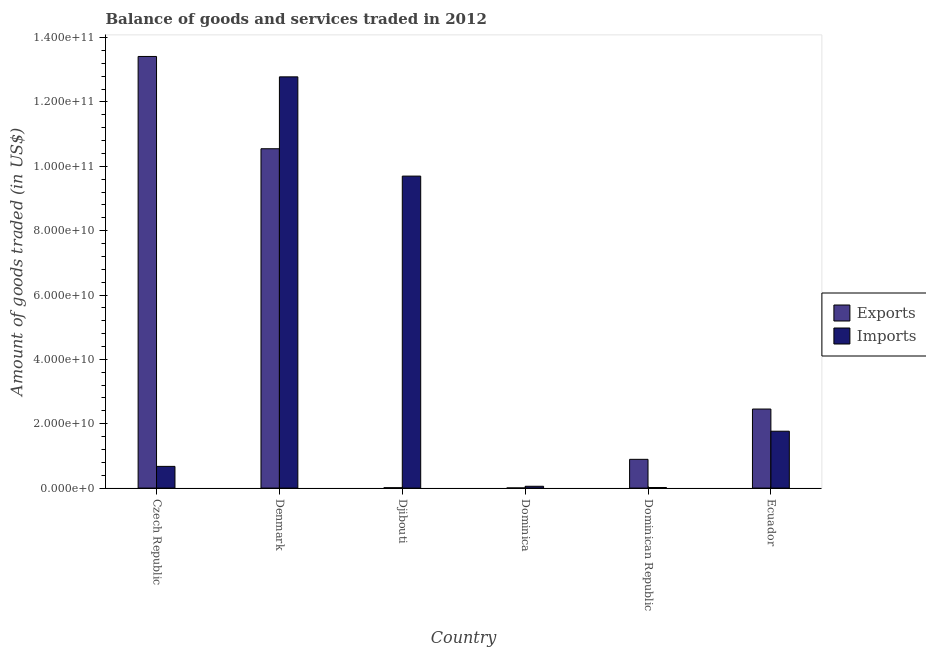How many different coloured bars are there?
Provide a short and direct response. 2. How many groups of bars are there?
Offer a terse response. 6. What is the label of the 5th group of bars from the left?
Your answer should be very brief. Dominican Republic. In how many cases, is the number of bars for a given country not equal to the number of legend labels?
Your answer should be very brief. 0. What is the amount of goods exported in Dominica?
Give a very brief answer. 3.86e+07. Across all countries, what is the maximum amount of goods exported?
Offer a terse response. 1.34e+11. Across all countries, what is the minimum amount of goods imported?
Your answer should be compact. 1.83e+08. In which country was the amount of goods imported maximum?
Ensure brevity in your answer.  Denmark. In which country was the amount of goods imported minimum?
Provide a succinct answer. Dominican Republic. What is the total amount of goods imported in the graph?
Offer a terse response. 2.50e+11. What is the difference between the amount of goods exported in Dominican Republic and that in Ecuador?
Your response must be concise. -1.56e+1. What is the difference between the amount of goods imported in Ecuador and the amount of goods exported in Djibouti?
Give a very brief answer. 1.76e+1. What is the average amount of goods exported per country?
Keep it short and to the point. 4.55e+1. What is the difference between the amount of goods imported and amount of goods exported in Dominica?
Your answer should be compact. 5.26e+08. In how many countries, is the amount of goods exported greater than 32000000000 US$?
Keep it short and to the point. 2. What is the ratio of the amount of goods exported in Denmark to that in Dominican Republic?
Offer a terse response. 11.8. Is the difference between the amount of goods exported in Czech Republic and Dominica greater than the difference between the amount of goods imported in Czech Republic and Dominica?
Your answer should be very brief. Yes. What is the difference between the highest and the second highest amount of goods imported?
Keep it short and to the point. 3.08e+1. What is the difference between the highest and the lowest amount of goods exported?
Your answer should be very brief. 1.34e+11. Is the sum of the amount of goods imported in Djibouti and Ecuador greater than the maximum amount of goods exported across all countries?
Ensure brevity in your answer.  No. What does the 2nd bar from the left in Djibouti represents?
Your answer should be compact. Imports. What does the 2nd bar from the right in Dominica represents?
Your answer should be compact. Exports. How many bars are there?
Offer a very short reply. 12. How many countries are there in the graph?
Ensure brevity in your answer.  6. Where does the legend appear in the graph?
Offer a very short reply. Center right. How many legend labels are there?
Ensure brevity in your answer.  2. How are the legend labels stacked?
Your answer should be compact. Vertical. What is the title of the graph?
Your answer should be compact. Balance of goods and services traded in 2012. What is the label or title of the Y-axis?
Make the answer very short. Amount of goods traded (in US$). What is the Amount of goods traded (in US$) of Exports in Czech Republic?
Your answer should be very brief. 1.34e+11. What is the Amount of goods traded (in US$) in Imports in Czech Republic?
Your answer should be very brief. 6.74e+09. What is the Amount of goods traded (in US$) of Exports in Denmark?
Offer a terse response. 1.05e+11. What is the Amount of goods traded (in US$) of Imports in Denmark?
Offer a terse response. 1.28e+11. What is the Amount of goods traded (in US$) in Exports in Djibouti?
Give a very brief answer. 1.11e+08. What is the Amount of goods traded (in US$) of Imports in Djibouti?
Provide a short and direct response. 9.69e+1. What is the Amount of goods traded (in US$) of Exports in Dominica?
Your answer should be very brief. 3.86e+07. What is the Amount of goods traded (in US$) of Imports in Dominica?
Your answer should be very brief. 5.64e+08. What is the Amount of goods traded (in US$) in Exports in Dominican Republic?
Keep it short and to the point. 8.94e+09. What is the Amount of goods traded (in US$) of Imports in Dominican Republic?
Offer a very short reply. 1.83e+08. What is the Amount of goods traded (in US$) of Exports in Ecuador?
Your answer should be compact. 2.46e+1. What is the Amount of goods traded (in US$) in Imports in Ecuador?
Your answer should be very brief. 1.77e+1. Across all countries, what is the maximum Amount of goods traded (in US$) of Exports?
Offer a terse response. 1.34e+11. Across all countries, what is the maximum Amount of goods traded (in US$) of Imports?
Your answer should be very brief. 1.28e+11. Across all countries, what is the minimum Amount of goods traded (in US$) in Exports?
Your answer should be very brief. 3.86e+07. Across all countries, what is the minimum Amount of goods traded (in US$) of Imports?
Give a very brief answer. 1.83e+08. What is the total Amount of goods traded (in US$) of Exports in the graph?
Offer a very short reply. 2.73e+11. What is the total Amount of goods traded (in US$) in Imports in the graph?
Your answer should be very brief. 2.50e+11. What is the difference between the Amount of goods traded (in US$) of Exports in Czech Republic and that in Denmark?
Offer a terse response. 2.87e+1. What is the difference between the Amount of goods traded (in US$) in Imports in Czech Republic and that in Denmark?
Your answer should be very brief. -1.21e+11. What is the difference between the Amount of goods traded (in US$) of Exports in Czech Republic and that in Djibouti?
Your response must be concise. 1.34e+11. What is the difference between the Amount of goods traded (in US$) in Imports in Czech Republic and that in Djibouti?
Ensure brevity in your answer.  -9.02e+1. What is the difference between the Amount of goods traded (in US$) in Exports in Czech Republic and that in Dominica?
Your answer should be very brief. 1.34e+11. What is the difference between the Amount of goods traded (in US$) in Imports in Czech Republic and that in Dominica?
Offer a terse response. 6.18e+09. What is the difference between the Amount of goods traded (in US$) of Exports in Czech Republic and that in Dominican Republic?
Your response must be concise. 1.25e+11. What is the difference between the Amount of goods traded (in US$) of Imports in Czech Republic and that in Dominican Republic?
Your answer should be compact. 6.56e+09. What is the difference between the Amount of goods traded (in US$) in Exports in Czech Republic and that in Ecuador?
Your answer should be very brief. 1.10e+11. What is the difference between the Amount of goods traded (in US$) in Imports in Czech Republic and that in Ecuador?
Ensure brevity in your answer.  -1.09e+1. What is the difference between the Amount of goods traded (in US$) in Exports in Denmark and that in Djibouti?
Your answer should be compact. 1.05e+11. What is the difference between the Amount of goods traded (in US$) of Imports in Denmark and that in Djibouti?
Your response must be concise. 3.08e+1. What is the difference between the Amount of goods traded (in US$) in Exports in Denmark and that in Dominica?
Provide a short and direct response. 1.05e+11. What is the difference between the Amount of goods traded (in US$) of Imports in Denmark and that in Dominica?
Offer a very short reply. 1.27e+11. What is the difference between the Amount of goods traded (in US$) in Exports in Denmark and that in Dominican Republic?
Offer a very short reply. 9.65e+1. What is the difference between the Amount of goods traded (in US$) of Imports in Denmark and that in Dominican Republic?
Your answer should be very brief. 1.28e+11. What is the difference between the Amount of goods traded (in US$) in Exports in Denmark and that in Ecuador?
Your response must be concise. 8.09e+1. What is the difference between the Amount of goods traded (in US$) in Imports in Denmark and that in Ecuador?
Make the answer very short. 1.10e+11. What is the difference between the Amount of goods traded (in US$) of Exports in Djibouti and that in Dominica?
Ensure brevity in your answer.  7.28e+07. What is the difference between the Amount of goods traded (in US$) in Imports in Djibouti and that in Dominica?
Offer a very short reply. 9.64e+1. What is the difference between the Amount of goods traded (in US$) of Exports in Djibouti and that in Dominican Republic?
Give a very brief answer. -8.82e+09. What is the difference between the Amount of goods traded (in US$) in Imports in Djibouti and that in Dominican Republic?
Your answer should be very brief. 9.68e+1. What is the difference between the Amount of goods traded (in US$) in Exports in Djibouti and that in Ecuador?
Keep it short and to the point. -2.45e+1. What is the difference between the Amount of goods traded (in US$) of Imports in Djibouti and that in Ecuador?
Make the answer very short. 7.93e+1. What is the difference between the Amount of goods traded (in US$) in Exports in Dominica and that in Dominican Republic?
Give a very brief answer. -8.90e+09. What is the difference between the Amount of goods traded (in US$) of Imports in Dominica and that in Dominican Republic?
Make the answer very short. 3.81e+08. What is the difference between the Amount of goods traded (in US$) of Exports in Dominica and that in Ecuador?
Your response must be concise. -2.45e+1. What is the difference between the Amount of goods traded (in US$) in Imports in Dominica and that in Ecuador?
Your answer should be compact. -1.71e+1. What is the difference between the Amount of goods traded (in US$) of Exports in Dominican Republic and that in Ecuador?
Provide a succinct answer. -1.56e+1. What is the difference between the Amount of goods traded (in US$) of Imports in Dominican Republic and that in Ecuador?
Your answer should be compact. -1.75e+1. What is the difference between the Amount of goods traded (in US$) of Exports in Czech Republic and the Amount of goods traded (in US$) of Imports in Denmark?
Provide a short and direct response. 6.34e+09. What is the difference between the Amount of goods traded (in US$) in Exports in Czech Republic and the Amount of goods traded (in US$) in Imports in Djibouti?
Keep it short and to the point. 3.72e+1. What is the difference between the Amount of goods traded (in US$) in Exports in Czech Republic and the Amount of goods traded (in US$) in Imports in Dominica?
Offer a terse response. 1.34e+11. What is the difference between the Amount of goods traded (in US$) in Exports in Czech Republic and the Amount of goods traded (in US$) in Imports in Dominican Republic?
Provide a short and direct response. 1.34e+11. What is the difference between the Amount of goods traded (in US$) in Exports in Czech Republic and the Amount of goods traded (in US$) in Imports in Ecuador?
Offer a very short reply. 1.16e+11. What is the difference between the Amount of goods traded (in US$) in Exports in Denmark and the Amount of goods traded (in US$) in Imports in Djibouti?
Give a very brief answer. 8.50e+09. What is the difference between the Amount of goods traded (in US$) in Exports in Denmark and the Amount of goods traded (in US$) in Imports in Dominica?
Offer a very short reply. 1.05e+11. What is the difference between the Amount of goods traded (in US$) of Exports in Denmark and the Amount of goods traded (in US$) of Imports in Dominican Republic?
Offer a terse response. 1.05e+11. What is the difference between the Amount of goods traded (in US$) of Exports in Denmark and the Amount of goods traded (in US$) of Imports in Ecuador?
Give a very brief answer. 8.78e+1. What is the difference between the Amount of goods traded (in US$) of Exports in Djibouti and the Amount of goods traded (in US$) of Imports in Dominica?
Your response must be concise. -4.53e+08. What is the difference between the Amount of goods traded (in US$) of Exports in Djibouti and the Amount of goods traded (in US$) of Imports in Dominican Republic?
Ensure brevity in your answer.  -7.20e+07. What is the difference between the Amount of goods traded (in US$) of Exports in Djibouti and the Amount of goods traded (in US$) of Imports in Ecuador?
Your response must be concise. -1.76e+1. What is the difference between the Amount of goods traded (in US$) of Exports in Dominica and the Amount of goods traded (in US$) of Imports in Dominican Republic?
Your response must be concise. -1.45e+08. What is the difference between the Amount of goods traded (in US$) of Exports in Dominica and the Amount of goods traded (in US$) of Imports in Ecuador?
Make the answer very short. -1.76e+1. What is the difference between the Amount of goods traded (in US$) in Exports in Dominican Republic and the Amount of goods traded (in US$) in Imports in Ecuador?
Provide a short and direct response. -8.74e+09. What is the average Amount of goods traded (in US$) of Exports per country?
Provide a short and direct response. 4.55e+1. What is the average Amount of goods traded (in US$) of Imports per country?
Give a very brief answer. 4.16e+1. What is the difference between the Amount of goods traded (in US$) of Exports and Amount of goods traded (in US$) of Imports in Czech Republic?
Provide a short and direct response. 1.27e+11. What is the difference between the Amount of goods traded (in US$) in Exports and Amount of goods traded (in US$) in Imports in Denmark?
Offer a very short reply. -2.23e+1. What is the difference between the Amount of goods traded (in US$) of Exports and Amount of goods traded (in US$) of Imports in Djibouti?
Your response must be concise. -9.68e+1. What is the difference between the Amount of goods traded (in US$) of Exports and Amount of goods traded (in US$) of Imports in Dominica?
Provide a succinct answer. -5.26e+08. What is the difference between the Amount of goods traded (in US$) in Exports and Amount of goods traded (in US$) in Imports in Dominican Republic?
Your answer should be very brief. 8.75e+09. What is the difference between the Amount of goods traded (in US$) in Exports and Amount of goods traded (in US$) in Imports in Ecuador?
Provide a succinct answer. 6.89e+09. What is the ratio of the Amount of goods traded (in US$) of Exports in Czech Republic to that in Denmark?
Keep it short and to the point. 1.27. What is the ratio of the Amount of goods traded (in US$) of Imports in Czech Republic to that in Denmark?
Your answer should be very brief. 0.05. What is the ratio of the Amount of goods traded (in US$) of Exports in Czech Republic to that in Djibouti?
Offer a terse response. 1204.43. What is the ratio of the Amount of goods traded (in US$) in Imports in Czech Republic to that in Djibouti?
Provide a succinct answer. 0.07. What is the ratio of the Amount of goods traded (in US$) in Exports in Czech Republic to that in Dominica?
Your answer should be very brief. 3475.21. What is the ratio of the Amount of goods traded (in US$) of Imports in Czech Republic to that in Dominica?
Ensure brevity in your answer.  11.95. What is the ratio of the Amount of goods traded (in US$) in Exports in Czech Republic to that in Dominican Republic?
Make the answer very short. 15.01. What is the ratio of the Amount of goods traded (in US$) of Imports in Czech Republic to that in Dominican Republic?
Ensure brevity in your answer.  36.79. What is the ratio of the Amount of goods traded (in US$) in Exports in Czech Republic to that in Ecuador?
Provide a succinct answer. 5.46. What is the ratio of the Amount of goods traded (in US$) of Imports in Czech Republic to that in Ecuador?
Ensure brevity in your answer.  0.38. What is the ratio of the Amount of goods traded (in US$) of Exports in Denmark to that in Djibouti?
Keep it short and to the point. 946.93. What is the ratio of the Amount of goods traded (in US$) in Imports in Denmark to that in Djibouti?
Ensure brevity in your answer.  1.32. What is the ratio of the Amount of goods traded (in US$) in Exports in Denmark to that in Dominica?
Make the answer very short. 2732.23. What is the ratio of the Amount of goods traded (in US$) of Imports in Denmark to that in Dominica?
Provide a succinct answer. 226.4. What is the ratio of the Amount of goods traded (in US$) in Exports in Denmark to that in Dominican Republic?
Keep it short and to the point. 11.8. What is the ratio of the Amount of goods traded (in US$) in Imports in Denmark to that in Dominican Republic?
Ensure brevity in your answer.  697.08. What is the ratio of the Amount of goods traded (in US$) of Exports in Denmark to that in Ecuador?
Make the answer very short. 4.29. What is the ratio of the Amount of goods traded (in US$) of Imports in Denmark to that in Ecuador?
Offer a very short reply. 7.23. What is the ratio of the Amount of goods traded (in US$) in Exports in Djibouti to that in Dominica?
Provide a short and direct response. 2.89. What is the ratio of the Amount of goods traded (in US$) in Imports in Djibouti to that in Dominica?
Give a very brief answer. 171.76. What is the ratio of the Amount of goods traded (in US$) in Exports in Djibouti to that in Dominican Republic?
Your response must be concise. 0.01. What is the ratio of the Amount of goods traded (in US$) of Imports in Djibouti to that in Dominican Republic?
Provide a succinct answer. 528.85. What is the ratio of the Amount of goods traded (in US$) of Exports in Djibouti to that in Ecuador?
Provide a succinct answer. 0. What is the ratio of the Amount of goods traded (in US$) in Imports in Djibouti to that in Ecuador?
Keep it short and to the point. 5.49. What is the ratio of the Amount of goods traded (in US$) in Exports in Dominica to that in Dominican Republic?
Make the answer very short. 0. What is the ratio of the Amount of goods traded (in US$) in Imports in Dominica to that in Dominican Republic?
Make the answer very short. 3.08. What is the ratio of the Amount of goods traded (in US$) in Exports in Dominica to that in Ecuador?
Offer a terse response. 0. What is the ratio of the Amount of goods traded (in US$) in Imports in Dominica to that in Ecuador?
Keep it short and to the point. 0.03. What is the ratio of the Amount of goods traded (in US$) in Exports in Dominican Republic to that in Ecuador?
Make the answer very short. 0.36. What is the ratio of the Amount of goods traded (in US$) of Imports in Dominican Republic to that in Ecuador?
Offer a terse response. 0.01. What is the difference between the highest and the second highest Amount of goods traded (in US$) in Exports?
Provide a short and direct response. 2.87e+1. What is the difference between the highest and the second highest Amount of goods traded (in US$) in Imports?
Ensure brevity in your answer.  3.08e+1. What is the difference between the highest and the lowest Amount of goods traded (in US$) of Exports?
Offer a very short reply. 1.34e+11. What is the difference between the highest and the lowest Amount of goods traded (in US$) in Imports?
Make the answer very short. 1.28e+11. 